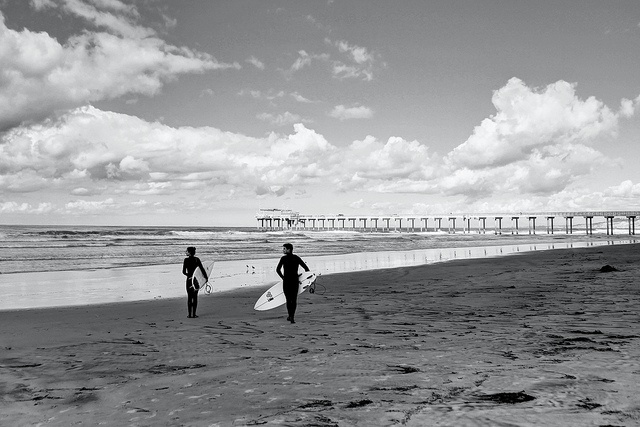Describe the objects in this image and their specific colors. I can see people in gray, black, darkgray, and lightgray tones, surfboard in gray, lightgray, darkgray, and black tones, people in gray, black, darkgray, and lightgray tones, and surfboard in gray, darkgray, black, and lightgray tones in this image. 